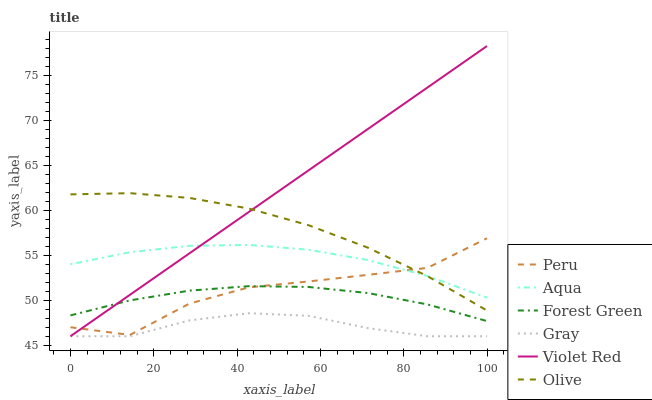Does Gray have the minimum area under the curve?
Answer yes or no. Yes. Does Violet Red have the maximum area under the curve?
Answer yes or no. Yes. Does Aqua have the minimum area under the curve?
Answer yes or no. No. Does Aqua have the maximum area under the curve?
Answer yes or no. No. Is Violet Red the smoothest?
Answer yes or no. Yes. Is Peru the roughest?
Answer yes or no. Yes. Is Aqua the smoothest?
Answer yes or no. No. Is Aqua the roughest?
Answer yes or no. No. Does Gray have the lowest value?
Answer yes or no. Yes. Does Aqua have the lowest value?
Answer yes or no. No. Does Violet Red have the highest value?
Answer yes or no. Yes. Does Aqua have the highest value?
Answer yes or no. No. Is Forest Green less than Olive?
Answer yes or no. Yes. Is Aqua greater than Gray?
Answer yes or no. Yes. Does Violet Red intersect Forest Green?
Answer yes or no. Yes. Is Violet Red less than Forest Green?
Answer yes or no. No. Is Violet Red greater than Forest Green?
Answer yes or no. No. Does Forest Green intersect Olive?
Answer yes or no. No. 